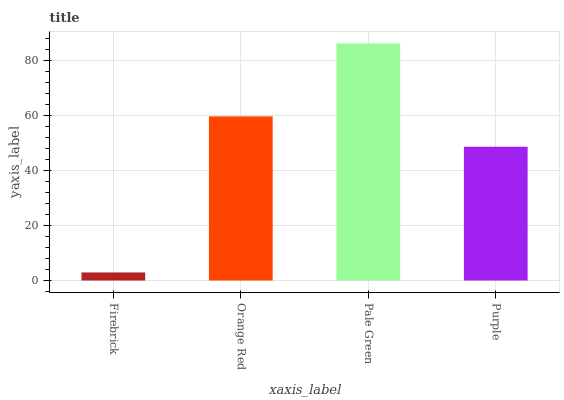Is Firebrick the minimum?
Answer yes or no. Yes. Is Pale Green the maximum?
Answer yes or no. Yes. Is Orange Red the minimum?
Answer yes or no. No. Is Orange Red the maximum?
Answer yes or no. No. Is Orange Red greater than Firebrick?
Answer yes or no. Yes. Is Firebrick less than Orange Red?
Answer yes or no. Yes. Is Firebrick greater than Orange Red?
Answer yes or no. No. Is Orange Red less than Firebrick?
Answer yes or no. No. Is Orange Red the high median?
Answer yes or no. Yes. Is Purple the low median?
Answer yes or no. Yes. Is Purple the high median?
Answer yes or no. No. Is Orange Red the low median?
Answer yes or no. No. 